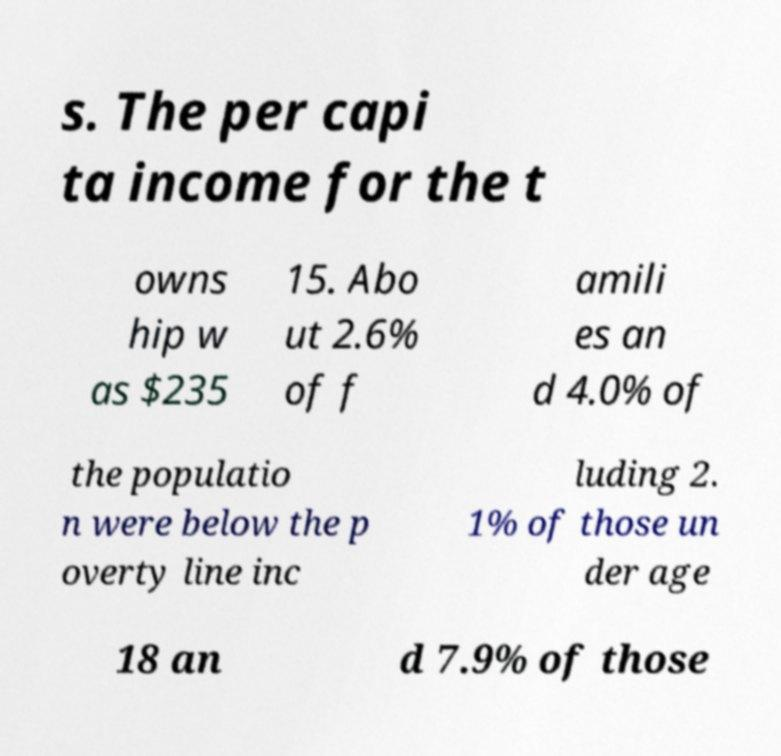For documentation purposes, I need the text within this image transcribed. Could you provide that? s. The per capi ta income for the t owns hip w as $235 15. Abo ut 2.6% of f amili es an d 4.0% of the populatio n were below the p overty line inc luding 2. 1% of those un der age 18 an d 7.9% of those 